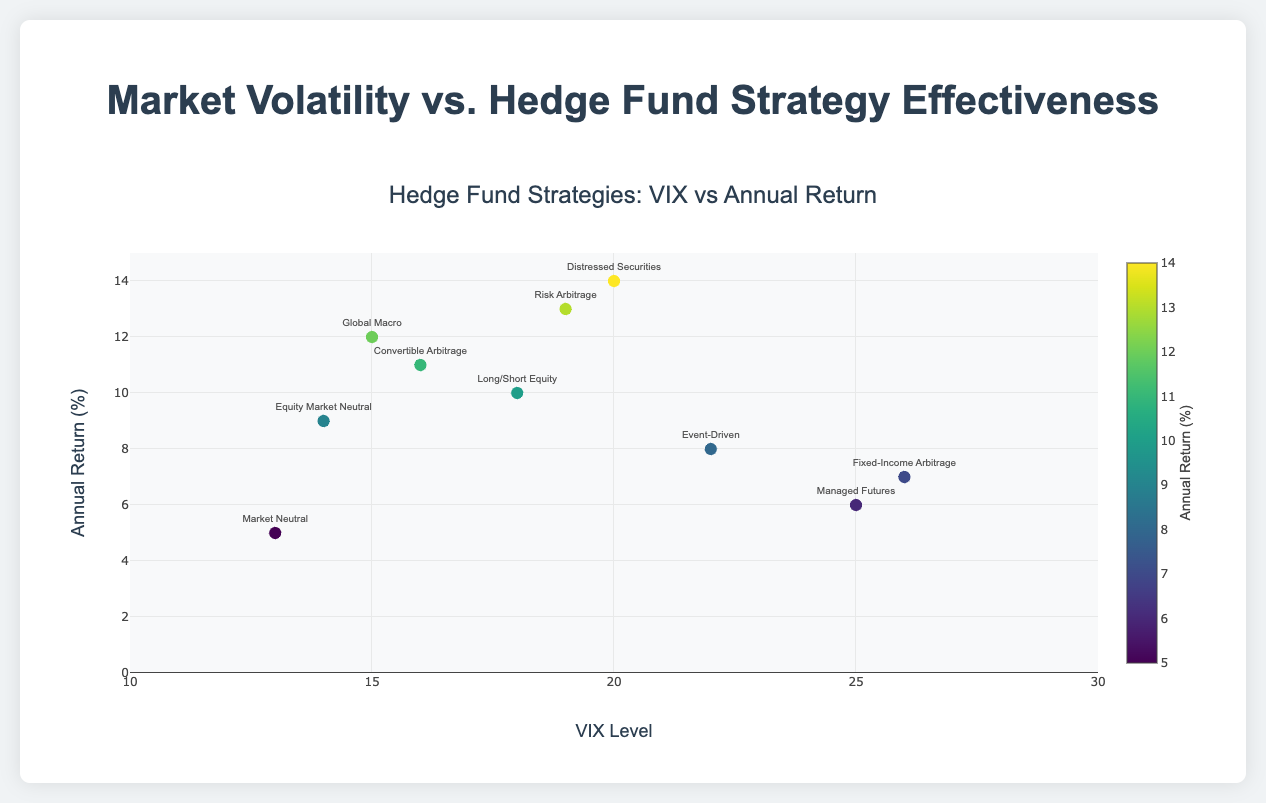Which hedge fund strategy displays the highest annual return percentage? By examining the y-axis, the highest point plotted corresponds to the "Distressed Securities" strategy with an annual return percentage of 14.
Answer: Distressed Securities What is the relationship between VIX level and annual return for the "Risk Arbitrage" strategy? Identify the "Risk Arbitrage" strategy data point, noted at a VIX level of 19. The corresponding point denotes an annual return percentage of 13. Therefore, for "Risk Arbitrage," a VIX level of 19 is related to a 13% return.
Answer: VIX 19, 13% return Which strategy is associated with the lowest annual return percentage and what is its VIX level? The lowest data point on the y-axis shows the "Market Neutral" strategy with a return of 5%. This point has a corresponding VIX level of 13.
Answer: Market Neutral, VIX 13 Is there a general trend observed between VIX levels and annual returns across different hedge fund strategies? Observing the scatter plot, there appears to be a general trend where higher VIX levels correspond to decreasing annual returns for the majority of strategies.
Answer: Higher VIX, Lower Returns Compare the return percentages of "Global Macro" and "Fixed-Income Arbitrage" strategies. Which one is higher and by how much? "Global Macro" has an annual return of 12%, and "Fixed-Income Arbitrage" has 7%. The difference is calculated as 12 - 7. Thus, "Global Macro" has a 5% higher return.
Answer: Global Macro, 5% Which strategies fall within a VIX level of 15 to 20 and what are their respective returns? The strategies within a VIX level of 15 to 20 are "Global Macro" (VIX 15, return 12%), "Long/Short Equity" (VIX 18, return 10%), "Convertible Arbitrage" (VIX 16, return 11%), and "Risk Arbitrage" (VIX 19, return 13%).
Answer: Global Macro 12%, Long/Short Equity 10%, Convertible Arbitrage 11%, Risk Arbitrage 13% Which strategy shows an annual return of 8%, and what is its associated VIX level? Locate the point on the y-axis at 8%. The "Event-Driven" strategy corresponds to this point, having an associated VIX level of 22.
Answer: Event-Driven, VIX 22 What is the VIX level associated with the median return percentage across all strategies? To find the median, arrange returns: 5%, 6%, 7%, 8%, 9%, 10%, 11%, 12%, 13%, 14%. The median is the average of the middle values (9% and 10%), so the median is 9.5%. The closest associated VIX level is 18.
Answer: VIX 18 Of "Managed Futures" and "Event-Driven" strategies, which one has a higher VIX level and annual return? "Managed Futures" has a VIX level of 25 and a return of 6%, whereas "Event-Driven" has a VIX level of 22 and a return of 8%. Although "Managed Futures" has a higher VIX level, "Event-Driven" shows a higher return.
Answer: Managed Futures has higher VIX, Event-Driven has higher return Which strategies' annual returns fall between 5% and 10%, inclusively, and what are their VIX levels? The strategies within the return range are "Market Neutral" (5%, VIX 13), "Managed Futures" (6%, VIX 25), "Fixed-Income Arbitrage" (7%, VIX 26), "Event-Driven" (8%, VIX 22), and "Equity Market Neutral" (9%, VIX 14).
Answer: Market Neutral 13, Managed Futures 25, Fixed-Income Arbitrage 26, Event-Driven 22, Equity Market Neutral 14 